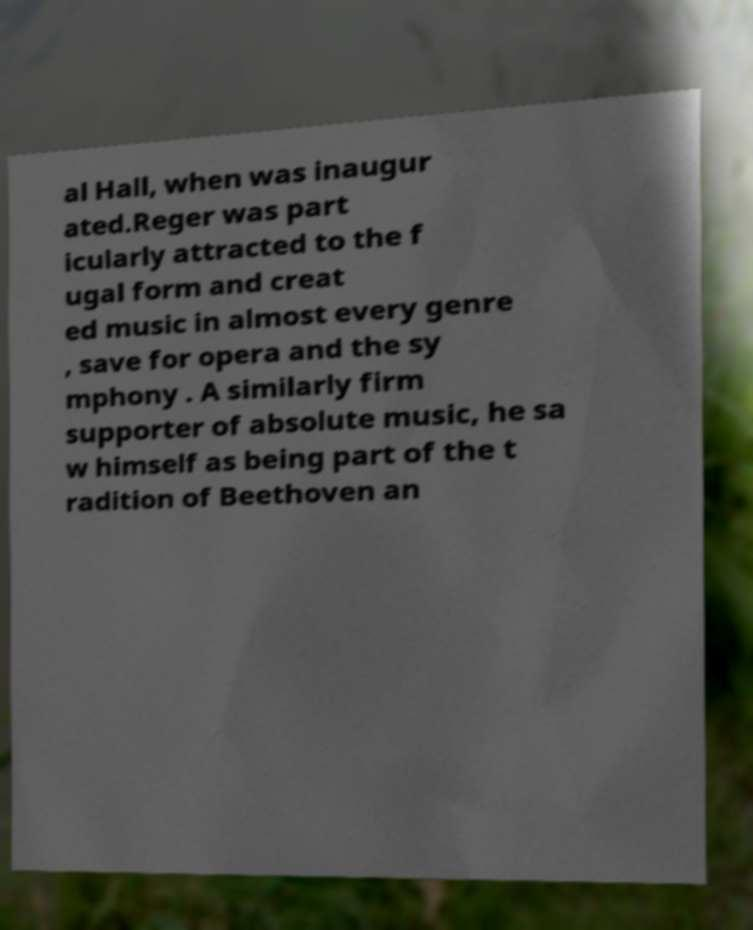Please identify and transcribe the text found in this image. al Hall, when was inaugur ated.Reger was part icularly attracted to the f ugal form and creat ed music in almost every genre , save for opera and the sy mphony . A similarly firm supporter of absolute music, he sa w himself as being part of the t radition of Beethoven an 